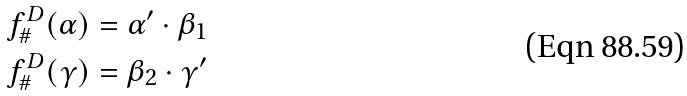<formula> <loc_0><loc_0><loc_500><loc_500>f ^ { D } _ { \# } ( \alpha ) & = \alpha ^ { \prime } \cdot \beta _ { 1 } \\ f ^ { D } _ { \# } ( \gamma ) & = \beta _ { 2 } \cdot \gamma ^ { \prime }</formula> 